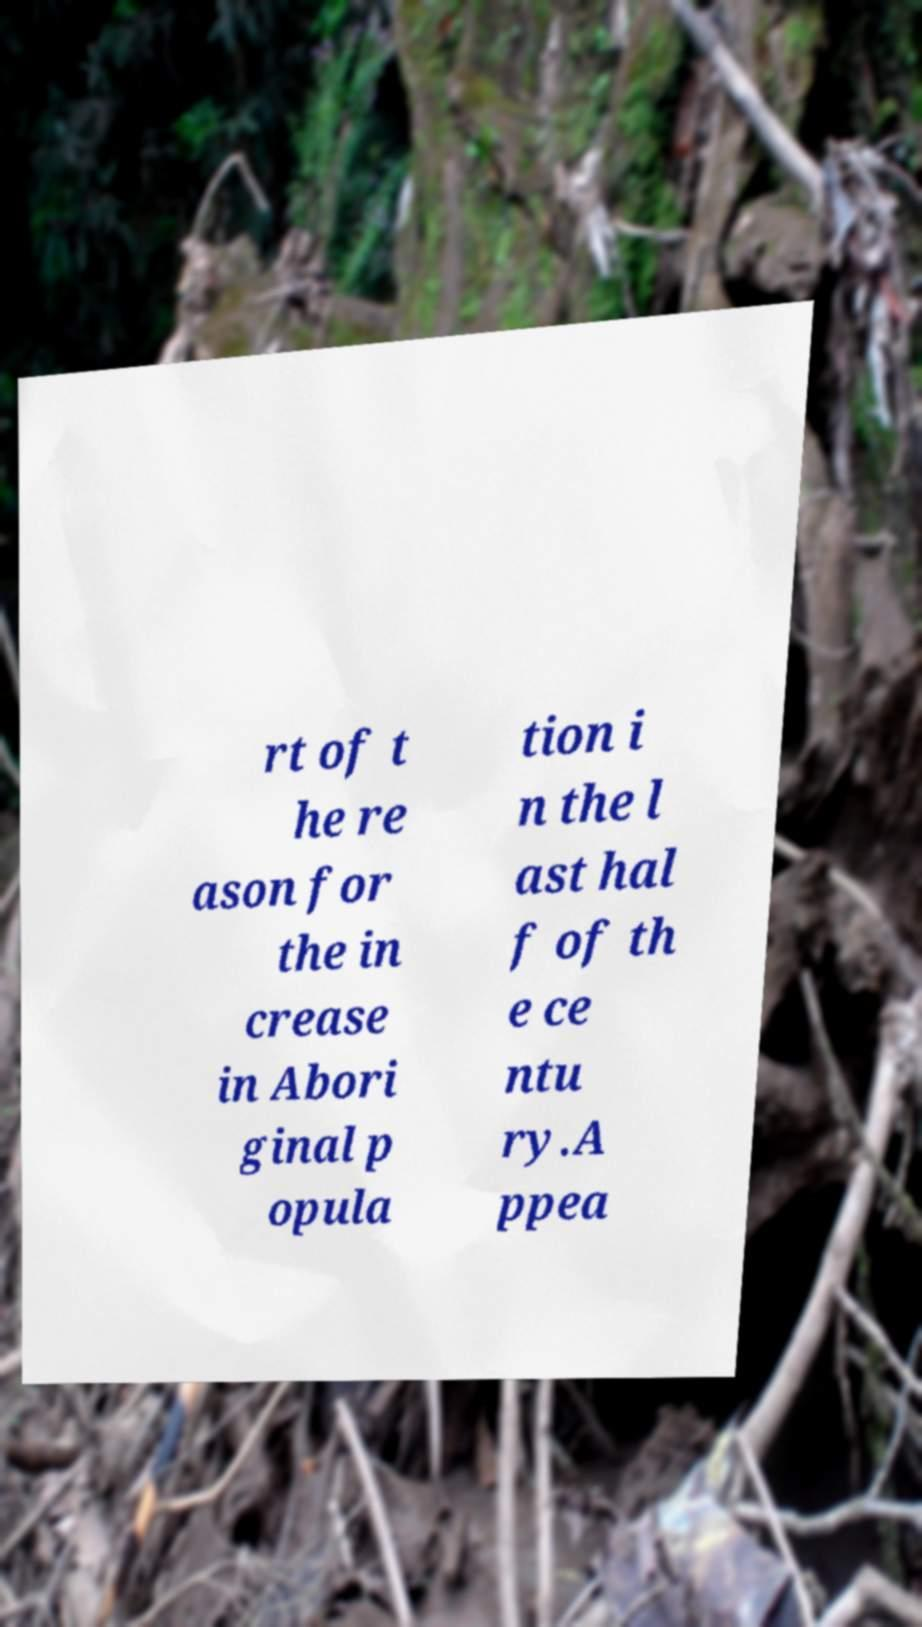Could you extract and type out the text from this image? rt of t he re ason for the in crease in Abori ginal p opula tion i n the l ast hal f of th e ce ntu ry.A ppea 